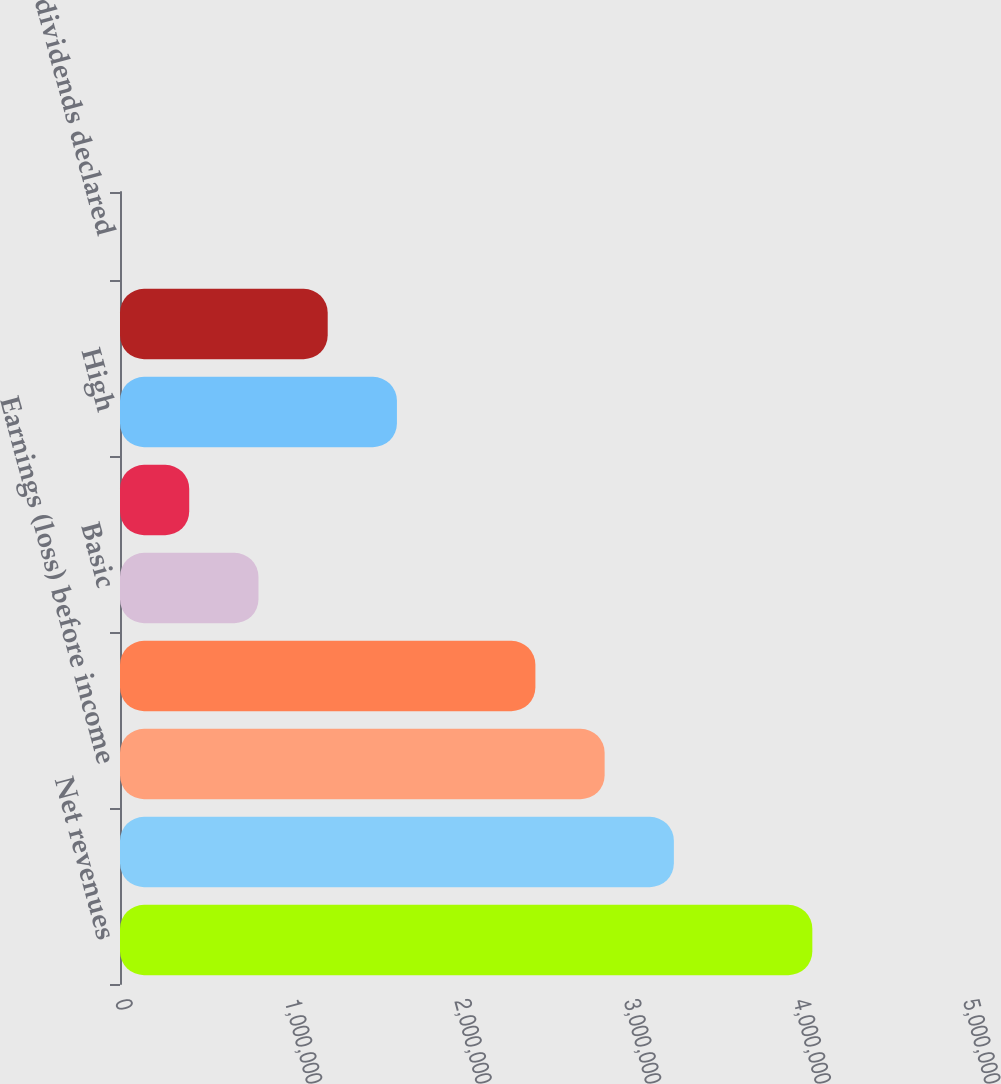<chart> <loc_0><loc_0><loc_500><loc_500><bar_chart><fcel>Net revenues<fcel>Operating profit<fcel>Earnings (loss) before income<fcel>Net earnings (loss)<fcel>Basic<fcel>Diluted<fcel>High<fcel>Low<fcel>Cash dividends declared<nl><fcel>4.08216e+06<fcel>3.26573e+06<fcel>2.85751e+06<fcel>2.44929e+06<fcel>816433<fcel>408217<fcel>1.63286e+06<fcel>1.22465e+06<fcel>1.6<nl></chart> 